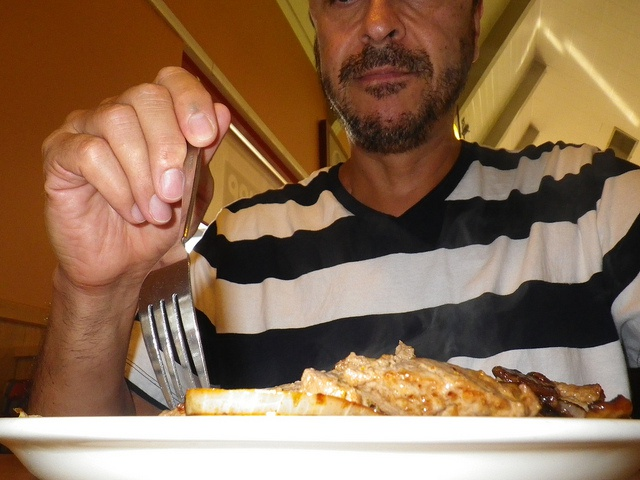Describe the objects in this image and their specific colors. I can see people in maroon, black, darkgray, and tan tones, bowl in maroon, white, darkgray, lightgray, and tan tones, and fork in maroon, darkgray, and gray tones in this image. 